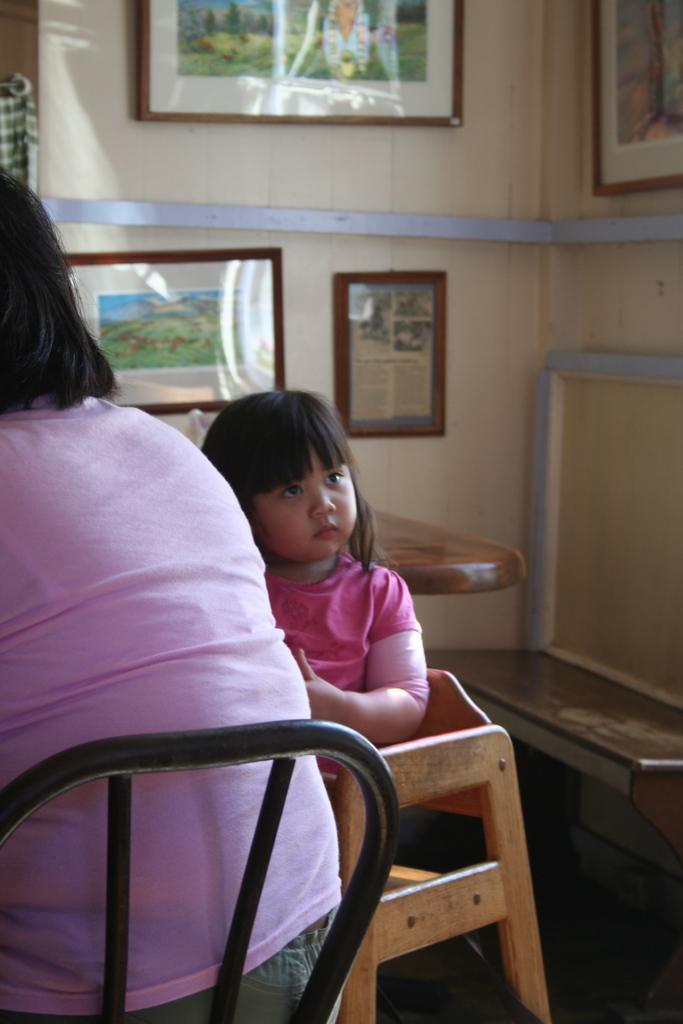Can you describe this image briefly? In this image we can see a person sitting on the chair. In the center we can see the girl. We can also see the table, bench and also the frames attached to the plain wall. We can also see the floor. 